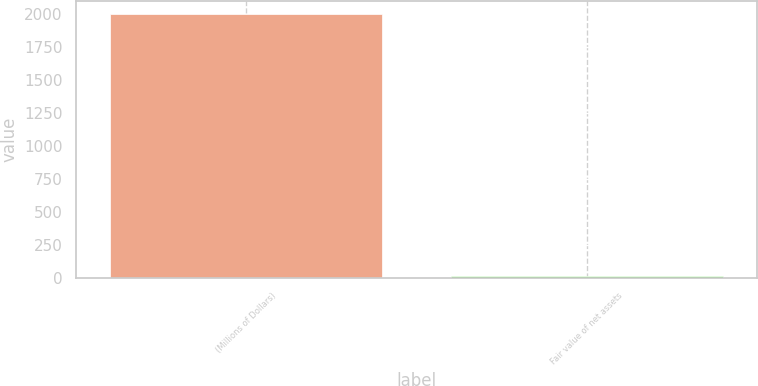Convert chart to OTSL. <chart><loc_0><loc_0><loc_500><loc_500><bar_chart><fcel>(Millions of Dollars)<fcel>Fair value of net assets<nl><fcel>2002<fcel>16<nl></chart> 